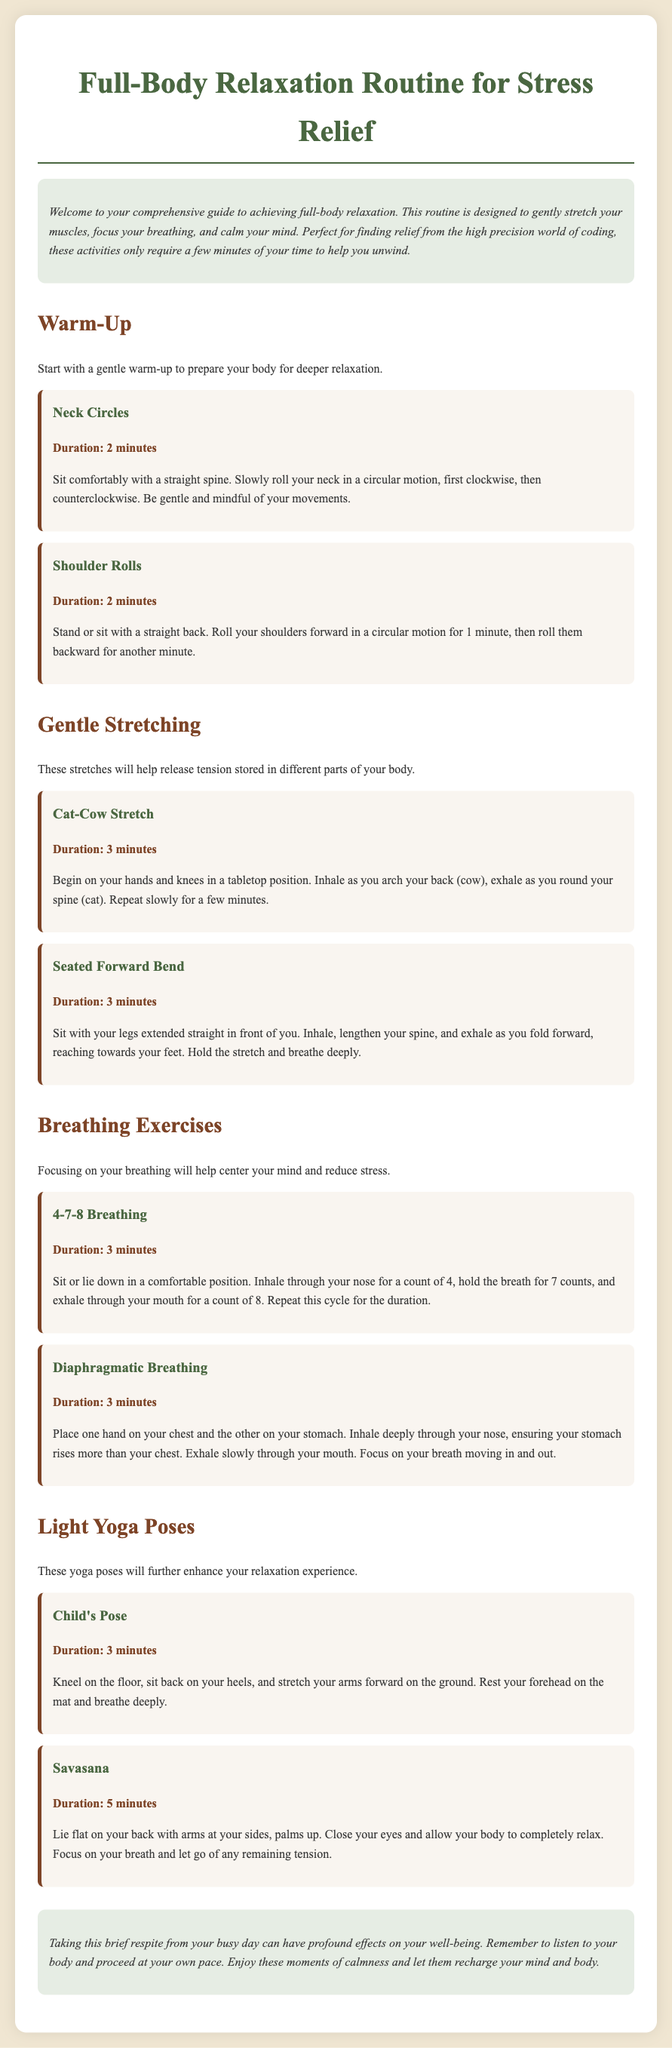What is the title of the document? The title can be found at the top of the document and indicates the main topic covered.
Answer: Full-Body Relaxation Routine for Stress Relief How long should you perform neck circles? The duration for each exercise is specified within the document, giving clear instruction on time.
Answer: 2 minutes What is the first step in the warm-up section? This question asks for the initial exercise listed in the warm-up segment of the routine.
Answer: Neck Circles Which breathing exercise involves inhaling for a count of 4? This queries about a specific breathing technique mentioned in the document.
Answer: 4-7-8 Breathing How many minutes should you hold Savasana? The specific duration for this yoga pose is provided in the document to guide the reader.
Answer: 5 minutes What is the purpose of the relaxation routine? This seeks to understand the overall goal or intention behind the exercises listed in the document.
Answer: To achieve full-body relaxation What should you focus on while practicing Diaphragmatic Breathing? This explores what the practitioner should concentrate on during this breathing exercise.
Answer: Your breath moving in and out How does the document suggest you feel during Savasana? This examines the emotional or physical state expected while performing this pose.
Answer: Completely relax 